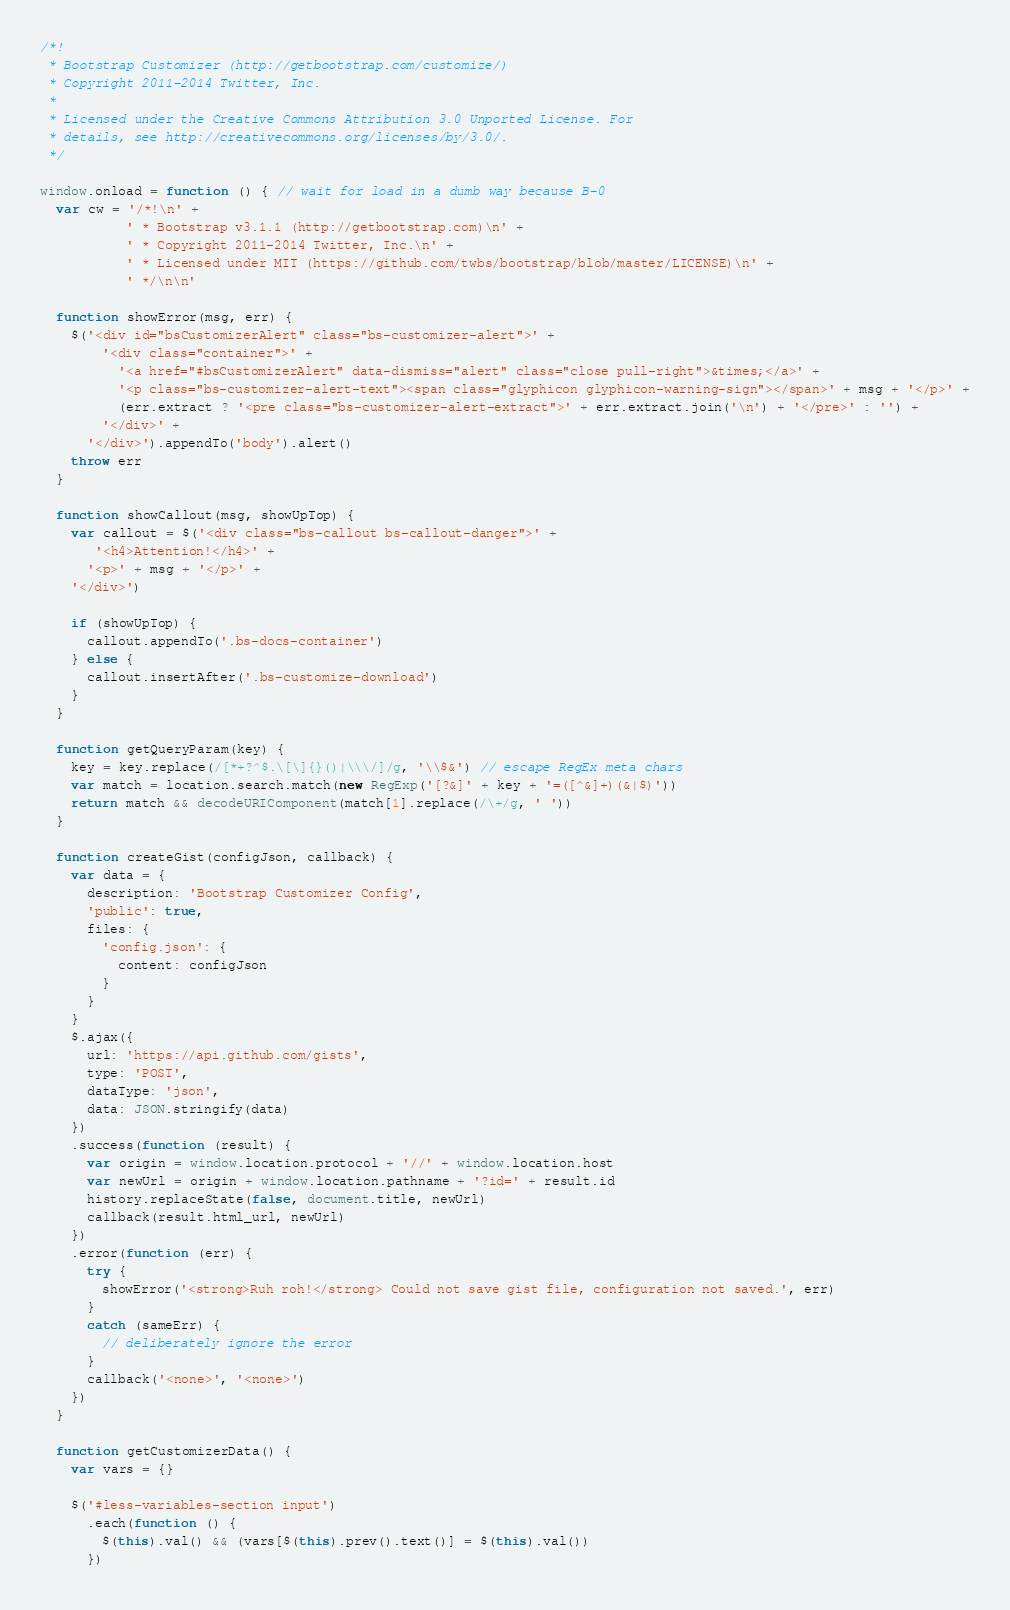Convert code to text. <code><loc_0><loc_0><loc_500><loc_500><_JavaScript_>/*!
 * Bootstrap Customizer (http://getbootstrap.com/customize/)
 * Copyright 2011-2014 Twitter, Inc.
 *
 * Licensed under the Creative Commons Attribution 3.0 Unported License. For
 * details, see http://creativecommons.org/licenses/by/3.0/.
 */

window.onload = function () { // wait for load in a dumb way because B-0
  var cw = '/*!\n' +
           ' * Bootstrap v3.1.1 (http://getbootstrap.com)\n' +
           ' * Copyright 2011-2014 Twitter, Inc.\n' +
           ' * Licensed under MIT (https://github.com/twbs/bootstrap/blob/master/LICENSE)\n' +
           ' */\n\n'

  function showError(msg, err) {
    $('<div id="bsCustomizerAlert" class="bs-customizer-alert">' +
        '<div class="container">' +
          '<a href="#bsCustomizerAlert" data-dismiss="alert" class="close pull-right">&times;</a>' +
          '<p class="bs-customizer-alert-text"><span class="glyphicon glyphicon-warning-sign"></span>' + msg + '</p>' +
          (err.extract ? '<pre class="bs-customizer-alert-extract">' + err.extract.join('\n') + '</pre>' : '') +
        '</div>' +
      '</div>').appendTo('body').alert()
    throw err
  }

  function showCallout(msg, showUpTop) {
    var callout = $('<div class="bs-callout bs-callout-danger">' +
       '<h4>Attention!</h4>' +
      '<p>' + msg + '</p>' +
    '</div>')

    if (showUpTop) {
      callout.appendTo('.bs-docs-container')
    } else {
      callout.insertAfter('.bs-customize-download')
    }
  }

  function getQueryParam(key) {
    key = key.replace(/[*+?^$.\[\]{}()|\\\/]/g, '\\$&') // escape RegEx meta chars
    var match = location.search.match(new RegExp('[?&]' + key + '=([^&]+)(&|$)'))
    return match && decodeURIComponent(match[1].replace(/\+/g, ' '))
  }

  function createGist(configJson, callback) {
    var data = {
      description: 'Bootstrap Customizer Config',
      'public': true,
      files: {
        'config.json': {
          content: configJson
        }
      }
    }
    $.ajax({
      url: 'https://api.github.com/gists',
      type: 'POST',
      dataType: 'json',
      data: JSON.stringify(data)
    })
    .success(function (result) {
      var origin = window.location.protocol + '//' + window.location.host
      var newUrl = origin + window.location.pathname + '?id=' + result.id
      history.replaceState(false, document.title, newUrl)
      callback(result.html_url, newUrl)
    })
    .error(function (err) {
      try {
        showError('<strong>Ruh roh!</strong> Could not save gist file, configuration not saved.', err)
      }
      catch (sameErr) {
        // deliberately ignore the error
      }
      callback('<none>', '<none>')
    })
  }

  function getCustomizerData() {
    var vars = {}

    $('#less-variables-section input')
      .each(function () {
        $(this).val() && (vars[$(this).prev().text()] = $(this).val())
      })
</code> 